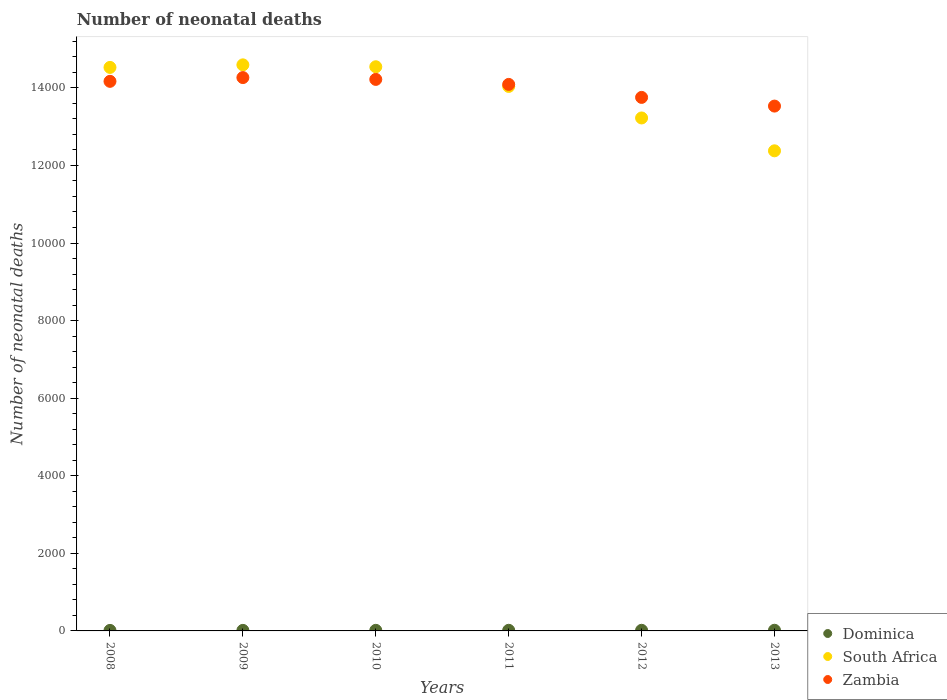Is the number of dotlines equal to the number of legend labels?
Your answer should be very brief. Yes. What is the number of neonatal deaths in in Zambia in 2008?
Make the answer very short. 1.42e+04. Across all years, what is the maximum number of neonatal deaths in in South Africa?
Give a very brief answer. 1.46e+04. Across all years, what is the minimum number of neonatal deaths in in South Africa?
Your answer should be compact. 1.24e+04. In which year was the number of neonatal deaths in in South Africa maximum?
Keep it short and to the point. 2009. In which year was the number of neonatal deaths in in South Africa minimum?
Your answer should be very brief. 2013. What is the total number of neonatal deaths in in South Africa in the graph?
Your answer should be compact. 8.33e+04. What is the difference between the number of neonatal deaths in in Zambia in 2008 and that in 2009?
Offer a terse response. -97. What is the difference between the number of neonatal deaths in in Dominica in 2013 and the number of neonatal deaths in in South Africa in 2012?
Offer a terse response. -1.32e+04. What is the average number of neonatal deaths in in South Africa per year?
Provide a short and direct response. 1.39e+04. In the year 2009, what is the difference between the number of neonatal deaths in in South Africa and number of neonatal deaths in in Dominica?
Make the answer very short. 1.46e+04. In how many years, is the number of neonatal deaths in in South Africa greater than 3200?
Ensure brevity in your answer.  6. What is the ratio of the number of neonatal deaths in in Zambia in 2012 to that in 2013?
Provide a succinct answer. 1.02. Is the difference between the number of neonatal deaths in in South Africa in 2009 and 2012 greater than the difference between the number of neonatal deaths in in Dominica in 2009 and 2012?
Offer a terse response. Yes. What is the difference between the highest and the second highest number of neonatal deaths in in Dominica?
Ensure brevity in your answer.  1. What is the difference between the highest and the lowest number of neonatal deaths in in Dominica?
Keep it short and to the point. 4. In how many years, is the number of neonatal deaths in in Zambia greater than the average number of neonatal deaths in in Zambia taken over all years?
Provide a short and direct response. 4. Is the number of neonatal deaths in in Zambia strictly greater than the number of neonatal deaths in in Dominica over the years?
Ensure brevity in your answer.  Yes. How many years are there in the graph?
Make the answer very short. 6. Are the values on the major ticks of Y-axis written in scientific E-notation?
Offer a very short reply. No. What is the title of the graph?
Your response must be concise. Number of neonatal deaths. What is the label or title of the X-axis?
Make the answer very short. Years. What is the label or title of the Y-axis?
Ensure brevity in your answer.  Number of neonatal deaths. What is the Number of neonatal deaths in Dominica in 2008?
Give a very brief answer. 13. What is the Number of neonatal deaths in South Africa in 2008?
Give a very brief answer. 1.45e+04. What is the Number of neonatal deaths in Zambia in 2008?
Provide a short and direct response. 1.42e+04. What is the Number of neonatal deaths in Dominica in 2009?
Ensure brevity in your answer.  14. What is the Number of neonatal deaths of South Africa in 2009?
Provide a succinct answer. 1.46e+04. What is the Number of neonatal deaths of Zambia in 2009?
Make the answer very short. 1.43e+04. What is the Number of neonatal deaths of Dominica in 2010?
Your answer should be very brief. 15. What is the Number of neonatal deaths of South Africa in 2010?
Provide a succinct answer. 1.45e+04. What is the Number of neonatal deaths of Zambia in 2010?
Your answer should be compact. 1.42e+04. What is the Number of neonatal deaths in Dominica in 2011?
Your response must be concise. 16. What is the Number of neonatal deaths in South Africa in 2011?
Provide a succinct answer. 1.40e+04. What is the Number of neonatal deaths in Zambia in 2011?
Your response must be concise. 1.41e+04. What is the Number of neonatal deaths of Dominica in 2012?
Your response must be concise. 16. What is the Number of neonatal deaths of South Africa in 2012?
Keep it short and to the point. 1.32e+04. What is the Number of neonatal deaths of Zambia in 2012?
Your answer should be very brief. 1.38e+04. What is the Number of neonatal deaths in Dominica in 2013?
Your answer should be compact. 17. What is the Number of neonatal deaths of South Africa in 2013?
Keep it short and to the point. 1.24e+04. What is the Number of neonatal deaths of Zambia in 2013?
Your response must be concise. 1.35e+04. Across all years, what is the maximum Number of neonatal deaths in South Africa?
Provide a short and direct response. 1.46e+04. Across all years, what is the maximum Number of neonatal deaths in Zambia?
Offer a very short reply. 1.43e+04. Across all years, what is the minimum Number of neonatal deaths of Dominica?
Provide a short and direct response. 13. Across all years, what is the minimum Number of neonatal deaths of South Africa?
Your answer should be very brief. 1.24e+04. Across all years, what is the minimum Number of neonatal deaths in Zambia?
Your answer should be very brief. 1.35e+04. What is the total Number of neonatal deaths in Dominica in the graph?
Provide a short and direct response. 91. What is the total Number of neonatal deaths of South Africa in the graph?
Make the answer very short. 8.33e+04. What is the total Number of neonatal deaths of Zambia in the graph?
Provide a short and direct response. 8.40e+04. What is the difference between the Number of neonatal deaths in Dominica in 2008 and that in 2009?
Give a very brief answer. -1. What is the difference between the Number of neonatal deaths in South Africa in 2008 and that in 2009?
Ensure brevity in your answer.  -66. What is the difference between the Number of neonatal deaths in Zambia in 2008 and that in 2009?
Offer a terse response. -97. What is the difference between the Number of neonatal deaths of Dominica in 2008 and that in 2010?
Your answer should be very brief. -2. What is the difference between the Number of neonatal deaths in South Africa in 2008 and that in 2011?
Ensure brevity in your answer.  490. What is the difference between the Number of neonatal deaths of Zambia in 2008 and that in 2011?
Offer a very short reply. 79. What is the difference between the Number of neonatal deaths in Dominica in 2008 and that in 2012?
Keep it short and to the point. -3. What is the difference between the Number of neonatal deaths of South Africa in 2008 and that in 2012?
Offer a terse response. 1303. What is the difference between the Number of neonatal deaths of Zambia in 2008 and that in 2012?
Offer a terse response. 414. What is the difference between the Number of neonatal deaths in South Africa in 2008 and that in 2013?
Your response must be concise. 2150. What is the difference between the Number of neonatal deaths in Zambia in 2008 and that in 2013?
Your response must be concise. 638. What is the difference between the Number of neonatal deaths in South Africa in 2009 and that in 2010?
Offer a terse response. 49. What is the difference between the Number of neonatal deaths in South Africa in 2009 and that in 2011?
Offer a very short reply. 556. What is the difference between the Number of neonatal deaths of Zambia in 2009 and that in 2011?
Your response must be concise. 176. What is the difference between the Number of neonatal deaths of Dominica in 2009 and that in 2012?
Give a very brief answer. -2. What is the difference between the Number of neonatal deaths of South Africa in 2009 and that in 2012?
Your answer should be compact. 1369. What is the difference between the Number of neonatal deaths in Zambia in 2009 and that in 2012?
Provide a short and direct response. 511. What is the difference between the Number of neonatal deaths in South Africa in 2009 and that in 2013?
Keep it short and to the point. 2216. What is the difference between the Number of neonatal deaths of Zambia in 2009 and that in 2013?
Make the answer very short. 735. What is the difference between the Number of neonatal deaths of South Africa in 2010 and that in 2011?
Give a very brief answer. 507. What is the difference between the Number of neonatal deaths of Zambia in 2010 and that in 2011?
Give a very brief answer. 129. What is the difference between the Number of neonatal deaths in Dominica in 2010 and that in 2012?
Keep it short and to the point. -1. What is the difference between the Number of neonatal deaths of South Africa in 2010 and that in 2012?
Provide a succinct answer. 1320. What is the difference between the Number of neonatal deaths of Zambia in 2010 and that in 2012?
Your response must be concise. 464. What is the difference between the Number of neonatal deaths in South Africa in 2010 and that in 2013?
Your response must be concise. 2167. What is the difference between the Number of neonatal deaths in Zambia in 2010 and that in 2013?
Your answer should be very brief. 688. What is the difference between the Number of neonatal deaths of Dominica in 2011 and that in 2012?
Provide a short and direct response. 0. What is the difference between the Number of neonatal deaths of South Africa in 2011 and that in 2012?
Your answer should be very brief. 813. What is the difference between the Number of neonatal deaths of Zambia in 2011 and that in 2012?
Provide a short and direct response. 335. What is the difference between the Number of neonatal deaths of South Africa in 2011 and that in 2013?
Keep it short and to the point. 1660. What is the difference between the Number of neonatal deaths in Zambia in 2011 and that in 2013?
Your response must be concise. 559. What is the difference between the Number of neonatal deaths of Dominica in 2012 and that in 2013?
Your answer should be compact. -1. What is the difference between the Number of neonatal deaths in South Africa in 2012 and that in 2013?
Keep it short and to the point. 847. What is the difference between the Number of neonatal deaths in Zambia in 2012 and that in 2013?
Offer a terse response. 224. What is the difference between the Number of neonatal deaths of Dominica in 2008 and the Number of neonatal deaths of South Africa in 2009?
Your answer should be compact. -1.46e+04. What is the difference between the Number of neonatal deaths of Dominica in 2008 and the Number of neonatal deaths of Zambia in 2009?
Provide a succinct answer. -1.43e+04. What is the difference between the Number of neonatal deaths in South Africa in 2008 and the Number of neonatal deaths in Zambia in 2009?
Provide a short and direct response. 262. What is the difference between the Number of neonatal deaths of Dominica in 2008 and the Number of neonatal deaths of South Africa in 2010?
Offer a very short reply. -1.45e+04. What is the difference between the Number of neonatal deaths in Dominica in 2008 and the Number of neonatal deaths in Zambia in 2010?
Offer a terse response. -1.42e+04. What is the difference between the Number of neonatal deaths of South Africa in 2008 and the Number of neonatal deaths of Zambia in 2010?
Your response must be concise. 309. What is the difference between the Number of neonatal deaths of Dominica in 2008 and the Number of neonatal deaths of South Africa in 2011?
Keep it short and to the point. -1.40e+04. What is the difference between the Number of neonatal deaths of Dominica in 2008 and the Number of neonatal deaths of Zambia in 2011?
Your answer should be compact. -1.41e+04. What is the difference between the Number of neonatal deaths of South Africa in 2008 and the Number of neonatal deaths of Zambia in 2011?
Make the answer very short. 438. What is the difference between the Number of neonatal deaths in Dominica in 2008 and the Number of neonatal deaths in South Africa in 2012?
Keep it short and to the point. -1.32e+04. What is the difference between the Number of neonatal deaths of Dominica in 2008 and the Number of neonatal deaths of Zambia in 2012?
Keep it short and to the point. -1.37e+04. What is the difference between the Number of neonatal deaths of South Africa in 2008 and the Number of neonatal deaths of Zambia in 2012?
Ensure brevity in your answer.  773. What is the difference between the Number of neonatal deaths of Dominica in 2008 and the Number of neonatal deaths of South Africa in 2013?
Provide a short and direct response. -1.24e+04. What is the difference between the Number of neonatal deaths of Dominica in 2008 and the Number of neonatal deaths of Zambia in 2013?
Ensure brevity in your answer.  -1.35e+04. What is the difference between the Number of neonatal deaths of South Africa in 2008 and the Number of neonatal deaths of Zambia in 2013?
Your response must be concise. 997. What is the difference between the Number of neonatal deaths of Dominica in 2009 and the Number of neonatal deaths of South Africa in 2010?
Offer a very short reply. -1.45e+04. What is the difference between the Number of neonatal deaths of Dominica in 2009 and the Number of neonatal deaths of Zambia in 2010?
Your answer should be compact. -1.42e+04. What is the difference between the Number of neonatal deaths of South Africa in 2009 and the Number of neonatal deaths of Zambia in 2010?
Your answer should be compact. 375. What is the difference between the Number of neonatal deaths in Dominica in 2009 and the Number of neonatal deaths in South Africa in 2011?
Your answer should be very brief. -1.40e+04. What is the difference between the Number of neonatal deaths of Dominica in 2009 and the Number of neonatal deaths of Zambia in 2011?
Offer a very short reply. -1.41e+04. What is the difference between the Number of neonatal deaths in South Africa in 2009 and the Number of neonatal deaths in Zambia in 2011?
Ensure brevity in your answer.  504. What is the difference between the Number of neonatal deaths of Dominica in 2009 and the Number of neonatal deaths of South Africa in 2012?
Keep it short and to the point. -1.32e+04. What is the difference between the Number of neonatal deaths of Dominica in 2009 and the Number of neonatal deaths of Zambia in 2012?
Offer a terse response. -1.37e+04. What is the difference between the Number of neonatal deaths of South Africa in 2009 and the Number of neonatal deaths of Zambia in 2012?
Offer a very short reply. 839. What is the difference between the Number of neonatal deaths in Dominica in 2009 and the Number of neonatal deaths in South Africa in 2013?
Provide a succinct answer. -1.24e+04. What is the difference between the Number of neonatal deaths in Dominica in 2009 and the Number of neonatal deaths in Zambia in 2013?
Offer a terse response. -1.35e+04. What is the difference between the Number of neonatal deaths of South Africa in 2009 and the Number of neonatal deaths of Zambia in 2013?
Provide a short and direct response. 1063. What is the difference between the Number of neonatal deaths of Dominica in 2010 and the Number of neonatal deaths of South Africa in 2011?
Ensure brevity in your answer.  -1.40e+04. What is the difference between the Number of neonatal deaths in Dominica in 2010 and the Number of neonatal deaths in Zambia in 2011?
Offer a very short reply. -1.41e+04. What is the difference between the Number of neonatal deaths in South Africa in 2010 and the Number of neonatal deaths in Zambia in 2011?
Keep it short and to the point. 455. What is the difference between the Number of neonatal deaths of Dominica in 2010 and the Number of neonatal deaths of South Africa in 2012?
Your response must be concise. -1.32e+04. What is the difference between the Number of neonatal deaths of Dominica in 2010 and the Number of neonatal deaths of Zambia in 2012?
Your answer should be compact. -1.37e+04. What is the difference between the Number of neonatal deaths of South Africa in 2010 and the Number of neonatal deaths of Zambia in 2012?
Ensure brevity in your answer.  790. What is the difference between the Number of neonatal deaths of Dominica in 2010 and the Number of neonatal deaths of South Africa in 2013?
Ensure brevity in your answer.  -1.24e+04. What is the difference between the Number of neonatal deaths in Dominica in 2010 and the Number of neonatal deaths in Zambia in 2013?
Give a very brief answer. -1.35e+04. What is the difference between the Number of neonatal deaths in South Africa in 2010 and the Number of neonatal deaths in Zambia in 2013?
Offer a very short reply. 1014. What is the difference between the Number of neonatal deaths of Dominica in 2011 and the Number of neonatal deaths of South Africa in 2012?
Offer a very short reply. -1.32e+04. What is the difference between the Number of neonatal deaths in Dominica in 2011 and the Number of neonatal deaths in Zambia in 2012?
Ensure brevity in your answer.  -1.37e+04. What is the difference between the Number of neonatal deaths of South Africa in 2011 and the Number of neonatal deaths of Zambia in 2012?
Your response must be concise. 283. What is the difference between the Number of neonatal deaths of Dominica in 2011 and the Number of neonatal deaths of South Africa in 2013?
Your answer should be compact. -1.24e+04. What is the difference between the Number of neonatal deaths in Dominica in 2011 and the Number of neonatal deaths in Zambia in 2013?
Provide a short and direct response. -1.35e+04. What is the difference between the Number of neonatal deaths in South Africa in 2011 and the Number of neonatal deaths in Zambia in 2013?
Offer a very short reply. 507. What is the difference between the Number of neonatal deaths in Dominica in 2012 and the Number of neonatal deaths in South Africa in 2013?
Your answer should be compact. -1.24e+04. What is the difference between the Number of neonatal deaths of Dominica in 2012 and the Number of neonatal deaths of Zambia in 2013?
Provide a succinct answer. -1.35e+04. What is the difference between the Number of neonatal deaths of South Africa in 2012 and the Number of neonatal deaths of Zambia in 2013?
Offer a very short reply. -306. What is the average Number of neonatal deaths in Dominica per year?
Keep it short and to the point. 15.17. What is the average Number of neonatal deaths of South Africa per year?
Your answer should be compact. 1.39e+04. What is the average Number of neonatal deaths of Zambia per year?
Provide a succinct answer. 1.40e+04. In the year 2008, what is the difference between the Number of neonatal deaths of Dominica and Number of neonatal deaths of South Africa?
Your answer should be compact. -1.45e+04. In the year 2008, what is the difference between the Number of neonatal deaths of Dominica and Number of neonatal deaths of Zambia?
Offer a very short reply. -1.42e+04. In the year 2008, what is the difference between the Number of neonatal deaths in South Africa and Number of neonatal deaths in Zambia?
Keep it short and to the point. 359. In the year 2009, what is the difference between the Number of neonatal deaths in Dominica and Number of neonatal deaths in South Africa?
Your answer should be compact. -1.46e+04. In the year 2009, what is the difference between the Number of neonatal deaths in Dominica and Number of neonatal deaths in Zambia?
Make the answer very short. -1.43e+04. In the year 2009, what is the difference between the Number of neonatal deaths in South Africa and Number of neonatal deaths in Zambia?
Keep it short and to the point. 328. In the year 2010, what is the difference between the Number of neonatal deaths in Dominica and Number of neonatal deaths in South Africa?
Give a very brief answer. -1.45e+04. In the year 2010, what is the difference between the Number of neonatal deaths in Dominica and Number of neonatal deaths in Zambia?
Provide a short and direct response. -1.42e+04. In the year 2010, what is the difference between the Number of neonatal deaths of South Africa and Number of neonatal deaths of Zambia?
Give a very brief answer. 326. In the year 2011, what is the difference between the Number of neonatal deaths in Dominica and Number of neonatal deaths in South Africa?
Keep it short and to the point. -1.40e+04. In the year 2011, what is the difference between the Number of neonatal deaths of Dominica and Number of neonatal deaths of Zambia?
Your answer should be compact. -1.41e+04. In the year 2011, what is the difference between the Number of neonatal deaths in South Africa and Number of neonatal deaths in Zambia?
Your answer should be compact. -52. In the year 2012, what is the difference between the Number of neonatal deaths in Dominica and Number of neonatal deaths in South Africa?
Provide a short and direct response. -1.32e+04. In the year 2012, what is the difference between the Number of neonatal deaths in Dominica and Number of neonatal deaths in Zambia?
Your response must be concise. -1.37e+04. In the year 2012, what is the difference between the Number of neonatal deaths in South Africa and Number of neonatal deaths in Zambia?
Provide a succinct answer. -530. In the year 2013, what is the difference between the Number of neonatal deaths in Dominica and Number of neonatal deaths in South Africa?
Provide a short and direct response. -1.24e+04. In the year 2013, what is the difference between the Number of neonatal deaths in Dominica and Number of neonatal deaths in Zambia?
Ensure brevity in your answer.  -1.35e+04. In the year 2013, what is the difference between the Number of neonatal deaths of South Africa and Number of neonatal deaths of Zambia?
Make the answer very short. -1153. What is the ratio of the Number of neonatal deaths in South Africa in 2008 to that in 2009?
Provide a short and direct response. 1. What is the ratio of the Number of neonatal deaths of Zambia in 2008 to that in 2009?
Offer a very short reply. 0.99. What is the ratio of the Number of neonatal deaths in Dominica in 2008 to that in 2010?
Your answer should be compact. 0.87. What is the ratio of the Number of neonatal deaths in Zambia in 2008 to that in 2010?
Make the answer very short. 1. What is the ratio of the Number of neonatal deaths in Dominica in 2008 to that in 2011?
Your answer should be compact. 0.81. What is the ratio of the Number of neonatal deaths of South Africa in 2008 to that in 2011?
Give a very brief answer. 1.03. What is the ratio of the Number of neonatal deaths in Zambia in 2008 to that in 2011?
Give a very brief answer. 1.01. What is the ratio of the Number of neonatal deaths in Dominica in 2008 to that in 2012?
Give a very brief answer. 0.81. What is the ratio of the Number of neonatal deaths in South Africa in 2008 to that in 2012?
Provide a short and direct response. 1.1. What is the ratio of the Number of neonatal deaths in Zambia in 2008 to that in 2012?
Ensure brevity in your answer.  1.03. What is the ratio of the Number of neonatal deaths of Dominica in 2008 to that in 2013?
Your answer should be very brief. 0.76. What is the ratio of the Number of neonatal deaths in South Africa in 2008 to that in 2013?
Offer a very short reply. 1.17. What is the ratio of the Number of neonatal deaths of Zambia in 2008 to that in 2013?
Your answer should be very brief. 1.05. What is the ratio of the Number of neonatal deaths in Dominica in 2009 to that in 2010?
Offer a terse response. 0.93. What is the ratio of the Number of neonatal deaths in Dominica in 2009 to that in 2011?
Make the answer very short. 0.88. What is the ratio of the Number of neonatal deaths in South Africa in 2009 to that in 2011?
Ensure brevity in your answer.  1.04. What is the ratio of the Number of neonatal deaths in Zambia in 2009 to that in 2011?
Provide a short and direct response. 1.01. What is the ratio of the Number of neonatal deaths of South Africa in 2009 to that in 2012?
Your answer should be very brief. 1.1. What is the ratio of the Number of neonatal deaths of Zambia in 2009 to that in 2012?
Give a very brief answer. 1.04. What is the ratio of the Number of neonatal deaths of Dominica in 2009 to that in 2013?
Your answer should be very brief. 0.82. What is the ratio of the Number of neonatal deaths of South Africa in 2009 to that in 2013?
Provide a succinct answer. 1.18. What is the ratio of the Number of neonatal deaths in Zambia in 2009 to that in 2013?
Your response must be concise. 1.05. What is the ratio of the Number of neonatal deaths of South Africa in 2010 to that in 2011?
Provide a succinct answer. 1.04. What is the ratio of the Number of neonatal deaths of Zambia in 2010 to that in 2011?
Offer a terse response. 1.01. What is the ratio of the Number of neonatal deaths of South Africa in 2010 to that in 2012?
Provide a short and direct response. 1.1. What is the ratio of the Number of neonatal deaths in Zambia in 2010 to that in 2012?
Keep it short and to the point. 1.03. What is the ratio of the Number of neonatal deaths of Dominica in 2010 to that in 2013?
Give a very brief answer. 0.88. What is the ratio of the Number of neonatal deaths of South Africa in 2010 to that in 2013?
Offer a terse response. 1.18. What is the ratio of the Number of neonatal deaths in Zambia in 2010 to that in 2013?
Give a very brief answer. 1.05. What is the ratio of the Number of neonatal deaths of Dominica in 2011 to that in 2012?
Your response must be concise. 1. What is the ratio of the Number of neonatal deaths of South Africa in 2011 to that in 2012?
Give a very brief answer. 1.06. What is the ratio of the Number of neonatal deaths in Zambia in 2011 to that in 2012?
Your answer should be compact. 1.02. What is the ratio of the Number of neonatal deaths in Dominica in 2011 to that in 2013?
Provide a succinct answer. 0.94. What is the ratio of the Number of neonatal deaths of South Africa in 2011 to that in 2013?
Your answer should be compact. 1.13. What is the ratio of the Number of neonatal deaths of Zambia in 2011 to that in 2013?
Keep it short and to the point. 1.04. What is the ratio of the Number of neonatal deaths in South Africa in 2012 to that in 2013?
Offer a very short reply. 1.07. What is the ratio of the Number of neonatal deaths of Zambia in 2012 to that in 2013?
Offer a very short reply. 1.02. What is the difference between the highest and the second highest Number of neonatal deaths in Dominica?
Ensure brevity in your answer.  1. What is the difference between the highest and the second highest Number of neonatal deaths of South Africa?
Make the answer very short. 49. What is the difference between the highest and the second highest Number of neonatal deaths in Zambia?
Provide a short and direct response. 47. What is the difference between the highest and the lowest Number of neonatal deaths in South Africa?
Your response must be concise. 2216. What is the difference between the highest and the lowest Number of neonatal deaths in Zambia?
Provide a short and direct response. 735. 